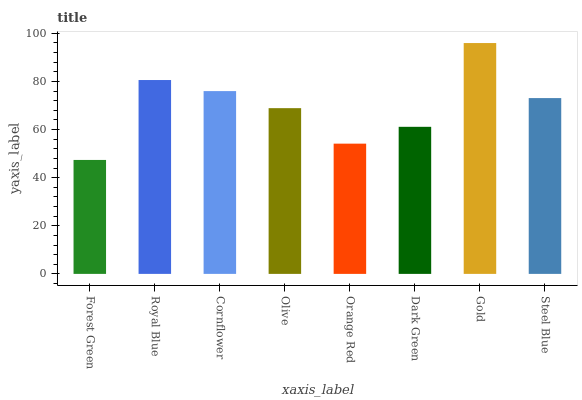Is Forest Green the minimum?
Answer yes or no. Yes. Is Gold the maximum?
Answer yes or no. Yes. Is Royal Blue the minimum?
Answer yes or no. No. Is Royal Blue the maximum?
Answer yes or no. No. Is Royal Blue greater than Forest Green?
Answer yes or no. Yes. Is Forest Green less than Royal Blue?
Answer yes or no. Yes. Is Forest Green greater than Royal Blue?
Answer yes or no. No. Is Royal Blue less than Forest Green?
Answer yes or no. No. Is Steel Blue the high median?
Answer yes or no. Yes. Is Olive the low median?
Answer yes or no. Yes. Is Dark Green the high median?
Answer yes or no. No. Is Dark Green the low median?
Answer yes or no. No. 